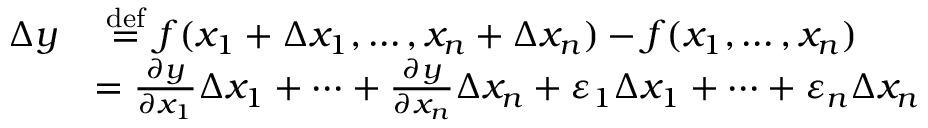Convert formula to latex. <formula><loc_0><loc_0><loc_500><loc_500>{ \begin{array} { r l } { \Delta y } & { { \stackrel { d e f } { = } } f ( x _ { 1 } + \Delta x _ { 1 } , \dots , x _ { n } + \Delta x _ { n } ) - f ( x _ { 1 } , \dots , x _ { n } ) } \\ & { = { \frac { \partial y } { \partial x _ { 1 } } } \Delta x _ { 1 } + \cdots + { \frac { \partial y } { \partial x _ { n } } } \Delta x _ { n } + \varepsilon _ { 1 } \Delta x _ { 1 } + \cdots + \varepsilon _ { n } \Delta x _ { n } } \end{array} }</formula> 